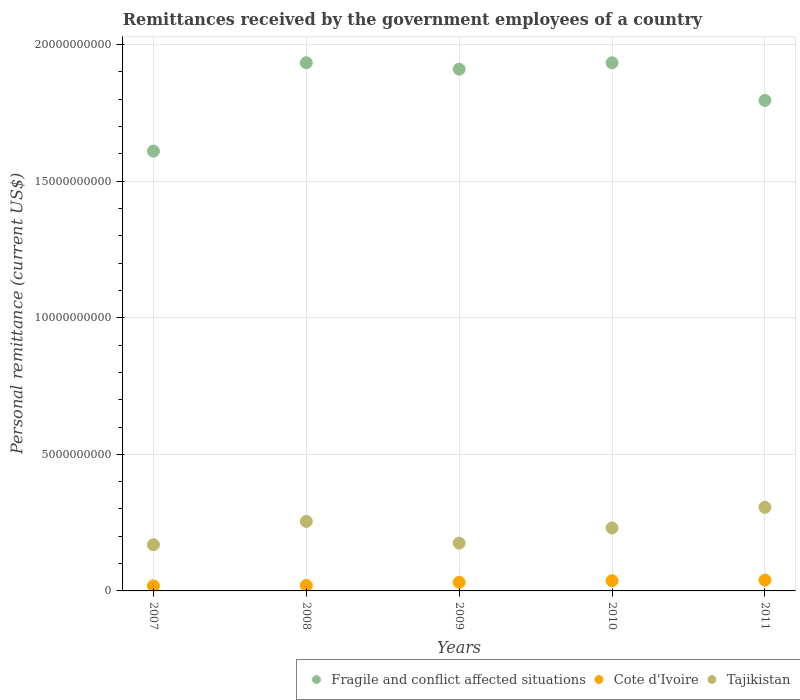What is the remittances received by the government employees in Fragile and conflict affected situations in 2007?
Offer a very short reply. 1.61e+1. Across all years, what is the maximum remittances received by the government employees in Tajikistan?
Your answer should be very brief. 3.06e+09. Across all years, what is the minimum remittances received by the government employees in Fragile and conflict affected situations?
Offer a very short reply. 1.61e+1. In which year was the remittances received by the government employees in Cote d'Ivoire minimum?
Your response must be concise. 2007. What is the total remittances received by the government employees in Fragile and conflict affected situations in the graph?
Provide a short and direct response. 9.18e+1. What is the difference between the remittances received by the government employees in Cote d'Ivoire in 2007 and that in 2011?
Make the answer very short. -2.12e+08. What is the difference between the remittances received by the government employees in Tajikistan in 2007 and the remittances received by the government employees in Cote d'Ivoire in 2009?
Provide a short and direct response. 1.38e+09. What is the average remittances received by the government employees in Tajikistan per year?
Provide a succinct answer. 2.27e+09. In the year 2010, what is the difference between the remittances received by the government employees in Cote d'Ivoire and remittances received by the government employees in Fragile and conflict affected situations?
Offer a very short reply. -1.90e+1. In how many years, is the remittances received by the government employees in Fragile and conflict affected situations greater than 4000000000 US$?
Ensure brevity in your answer.  5. What is the ratio of the remittances received by the government employees in Cote d'Ivoire in 2007 to that in 2010?
Provide a succinct answer. 0.49. Is the difference between the remittances received by the government employees in Cote d'Ivoire in 2010 and 2011 greater than the difference between the remittances received by the government employees in Fragile and conflict affected situations in 2010 and 2011?
Your response must be concise. No. What is the difference between the highest and the second highest remittances received by the government employees in Fragile and conflict affected situations?
Provide a short and direct response. 2.06e+06. What is the difference between the highest and the lowest remittances received by the government employees in Cote d'Ivoire?
Make the answer very short. 2.12e+08. Is the sum of the remittances received by the government employees in Tajikistan in 2008 and 2011 greater than the maximum remittances received by the government employees in Fragile and conflict affected situations across all years?
Your answer should be very brief. No. Is it the case that in every year, the sum of the remittances received by the government employees in Cote d'Ivoire and remittances received by the government employees in Fragile and conflict affected situations  is greater than the remittances received by the government employees in Tajikistan?
Give a very brief answer. Yes. Does the remittances received by the government employees in Tajikistan monotonically increase over the years?
Keep it short and to the point. No. Is the remittances received by the government employees in Tajikistan strictly greater than the remittances received by the government employees in Fragile and conflict affected situations over the years?
Offer a very short reply. No. How many dotlines are there?
Make the answer very short. 3. How many years are there in the graph?
Provide a succinct answer. 5. Are the values on the major ticks of Y-axis written in scientific E-notation?
Your response must be concise. No. Does the graph contain any zero values?
Your response must be concise. No. Does the graph contain grids?
Give a very brief answer. Yes. Where does the legend appear in the graph?
Keep it short and to the point. Bottom right. How many legend labels are there?
Your answer should be compact. 3. How are the legend labels stacked?
Ensure brevity in your answer.  Horizontal. What is the title of the graph?
Ensure brevity in your answer.  Remittances received by the government employees of a country. What is the label or title of the X-axis?
Provide a succinct answer. Years. What is the label or title of the Y-axis?
Make the answer very short. Personal remittance (current US$). What is the Personal remittance (current US$) of Fragile and conflict affected situations in 2007?
Give a very brief answer. 1.61e+1. What is the Personal remittance (current US$) in Cote d'Ivoire in 2007?
Make the answer very short. 1.85e+08. What is the Personal remittance (current US$) of Tajikistan in 2007?
Keep it short and to the point. 1.69e+09. What is the Personal remittance (current US$) of Fragile and conflict affected situations in 2008?
Keep it short and to the point. 1.93e+1. What is the Personal remittance (current US$) of Cote d'Ivoire in 2008?
Offer a terse response. 1.99e+08. What is the Personal remittance (current US$) in Tajikistan in 2008?
Give a very brief answer. 2.54e+09. What is the Personal remittance (current US$) in Fragile and conflict affected situations in 2009?
Ensure brevity in your answer.  1.91e+1. What is the Personal remittance (current US$) in Cote d'Ivoire in 2009?
Provide a short and direct response. 3.15e+08. What is the Personal remittance (current US$) in Tajikistan in 2009?
Give a very brief answer. 1.75e+09. What is the Personal remittance (current US$) of Fragile and conflict affected situations in 2010?
Offer a very short reply. 1.93e+1. What is the Personal remittance (current US$) of Cote d'Ivoire in 2010?
Your response must be concise. 3.73e+08. What is the Personal remittance (current US$) in Tajikistan in 2010?
Provide a short and direct response. 2.31e+09. What is the Personal remittance (current US$) of Fragile and conflict affected situations in 2011?
Ensure brevity in your answer.  1.80e+1. What is the Personal remittance (current US$) of Cote d'Ivoire in 2011?
Offer a terse response. 3.97e+08. What is the Personal remittance (current US$) of Tajikistan in 2011?
Provide a short and direct response. 3.06e+09. Across all years, what is the maximum Personal remittance (current US$) in Fragile and conflict affected situations?
Offer a terse response. 1.93e+1. Across all years, what is the maximum Personal remittance (current US$) of Cote d'Ivoire?
Keep it short and to the point. 3.97e+08. Across all years, what is the maximum Personal remittance (current US$) in Tajikistan?
Keep it short and to the point. 3.06e+09. Across all years, what is the minimum Personal remittance (current US$) of Fragile and conflict affected situations?
Make the answer very short. 1.61e+1. Across all years, what is the minimum Personal remittance (current US$) of Cote d'Ivoire?
Ensure brevity in your answer.  1.85e+08. Across all years, what is the minimum Personal remittance (current US$) in Tajikistan?
Offer a terse response. 1.69e+09. What is the total Personal remittance (current US$) of Fragile and conflict affected situations in the graph?
Provide a short and direct response. 9.18e+1. What is the total Personal remittance (current US$) in Cote d'Ivoire in the graph?
Your answer should be compact. 1.47e+09. What is the total Personal remittance (current US$) of Tajikistan in the graph?
Offer a terse response. 1.13e+1. What is the difference between the Personal remittance (current US$) of Fragile and conflict affected situations in 2007 and that in 2008?
Provide a succinct answer. -3.24e+09. What is the difference between the Personal remittance (current US$) of Cote d'Ivoire in 2007 and that in 2008?
Provide a short and direct response. -1.42e+07. What is the difference between the Personal remittance (current US$) in Tajikistan in 2007 and that in 2008?
Provide a short and direct response. -8.53e+08. What is the difference between the Personal remittance (current US$) in Fragile and conflict affected situations in 2007 and that in 2009?
Provide a succinct answer. -3.00e+09. What is the difference between the Personal remittance (current US$) of Cote d'Ivoire in 2007 and that in 2009?
Ensure brevity in your answer.  -1.30e+08. What is the difference between the Personal remittance (current US$) of Tajikistan in 2007 and that in 2009?
Offer a very short reply. -5.74e+07. What is the difference between the Personal remittance (current US$) in Fragile and conflict affected situations in 2007 and that in 2010?
Your answer should be very brief. -3.23e+09. What is the difference between the Personal remittance (current US$) of Cote d'Ivoire in 2007 and that in 2010?
Provide a succinct answer. -1.89e+08. What is the difference between the Personal remittance (current US$) in Tajikistan in 2007 and that in 2010?
Give a very brief answer. -6.15e+08. What is the difference between the Personal remittance (current US$) in Fragile and conflict affected situations in 2007 and that in 2011?
Provide a short and direct response. -1.86e+09. What is the difference between the Personal remittance (current US$) in Cote d'Ivoire in 2007 and that in 2011?
Offer a very short reply. -2.12e+08. What is the difference between the Personal remittance (current US$) of Tajikistan in 2007 and that in 2011?
Offer a very short reply. -1.37e+09. What is the difference between the Personal remittance (current US$) in Fragile and conflict affected situations in 2008 and that in 2009?
Your response must be concise. 2.36e+08. What is the difference between the Personal remittance (current US$) of Cote d'Ivoire in 2008 and that in 2009?
Give a very brief answer. -1.16e+08. What is the difference between the Personal remittance (current US$) of Tajikistan in 2008 and that in 2009?
Ensure brevity in your answer.  7.96e+08. What is the difference between the Personal remittance (current US$) in Fragile and conflict affected situations in 2008 and that in 2010?
Make the answer very short. 2.06e+06. What is the difference between the Personal remittance (current US$) in Cote d'Ivoire in 2008 and that in 2010?
Provide a succinct answer. -1.75e+08. What is the difference between the Personal remittance (current US$) in Tajikistan in 2008 and that in 2010?
Ensure brevity in your answer.  2.38e+08. What is the difference between the Personal remittance (current US$) of Fragile and conflict affected situations in 2008 and that in 2011?
Keep it short and to the point. 1.38e+09. What is the difference between the Personal remittance (current US$) in Cote d'Ivoire in 2008 and that in 2011?
Ensure brevity in your answer.  -1.98e+08. What is the difference between the Personal remittance (current US$) of Tajikistan in 2008 and that in 2011?
Make the answer very short. -5.16e+08. What is the difference between the Personal remittance (current US$) of Fragile and conflict affected situations in 2009 and that in 2010?
Offer a very short reply. -2.34e+08. What is the difference between the Personal remittance (current US$) in Cote d'Ivoire in 2009 and that in 2010?
Provide a succinct answer. -5.84e+07. What is the difference between the Personal remittance (current US$) of Tajikistan in 2009 and that in 2010?
Provide a succinct answer. -5.58e+08. What is the difference between the Personal remittance (current US$) of Fragile and conflict affected situations in 2009 and that in 2011?
Your answer should be compact. 1.14e+09. What is the difference between the Personal remittance (current US$) of Cote d'Ivoire in 2009 and that in 2011?
Offer a terse response. -8.15e+07. What is the difference between the Personal remittance (current US$) in Tajikistan in 2009 and that in 2011?
Your answer should be very brief. -1.31e+09. What is the difference between the Personal remittance (current US$) in Fragile and conflict affected situations in 2010 and that in 2011?
Ensure brevity in your answer.  1.38e+09. What is the difference between the Personal remittance (current US$) in Cote d'Ivoire in 2010 and that in 2011?
Your answer should be very brief. -2.31e+07. What is the difference between the Personal remittance (current US$) of Tajikistan in 2010 and that in 2011?
Ensure brevity in your answer.  -7.54e+08. What is the difference between the Personal remittance (current US$) of Fragile and conflict affected situations in 2007 and the Personal remittance (current US$) of Cote d'Ivoire in 2008?
Keep it short and to the point. 1.59e+1. What is the difference between the Personal remittance (current US$) in Fragile and conflict affected situations in 2007 and the Personal remittance (current US$) in Tajikistan in 2008?
Provide a short and direct response. 1.36e+1. What is the difference between the Personal remittance (current US$) of Cote d'Ivoire in 2007 and the Personal remittance (current US$) of Tajikistan in 2008?
Your answer should be compact. -2.36e+09. What is the difference between the Personal remittance (current US$) in Fragile and conflict affected situations in 2007 and the Personal remittance (current US$) in Cote d'Ivoire in 2009?
Give a very brief answer. 1.58e+1. What is the difference between the Personal remittance (current US$) in Fragile and conflict affected situations in 2007 and the Personal remittance (current US$) in Tajikistan in 2009?
Make the answer very short. 1.43e+1. What is the difference between the Personal remittance (current US$) in Cote d'Ivoire in 2007 and the Personal remittance (current US$) in Tajikistan in 2009?
Ensure brevity in your answer.  -1.56e+09. What is the difference between the Personal remittance (current US$) in Fragile and conflict affected situations in 2007 and the Personal remittance (current US$) in Cote d'Ivoire in 2010?
Your answer should be very brief. 1.57e+1. What is the difference between the Personal remittance (current US$) of Fragile and conflict affected situations in 2007 and the Personal remittance (current US$) of Tajikistan in 2010?
Offer a very short reply. 1.38e+1. What is the difference between the Personal remittance (current US$) in Cote d'Ivoire in 2007 and the Personal remittance (current US$) in Tajikistan in 2010?
Ensure brevity in your answer.  -2.12e+09. What is the difference between the Personal remittance (current US$) in Fragile and conflict affected situations in 2007 and the Personal remittance (current US$) in Cote d'Ivoire in 2011?
Your answer should be compact. 1.57e+1. What is the difference between the Personal remittance (current US$) of Fragile and conflict affected situations in 2007 and the Personal remittance (current US$) of Tajikistan in 2011?
Make the answer very short. 1.30e+1. What is the difference between the Personal remittance (current US$) in Cote d'Ivoire in 2007 and the Personal remittance (current US$) in Tajikistan in 2011?
Your answer should be compact. -2.88e+09. What is the difference between the Personal remittance (current US$) of Fragile and conflict affected situations in 2008 and the Personal remittance (current US$) of Cote d'Ivoire in 2009?
Your response must be concise. 1.90e+1. What is the difference between the Personal remittance (current US$) in Fragile and conflict affected situations in 2008 and the Personal remittance (current US$) in Tajikistan in 2009?
Give a very brief answer. 1.76e+1. What is the difference between the Personal remittance (current US$) of Cote d'Ivoire in 2008 and the Personal remittance (current US$) of Tajikistan in 2009?
Provide a succinct answer. -1.55e+09. What is the difference between the Personal remittance (current US$) in Fragile and conflict affected situations in 2008 and the Personal remittance (current US$) in Cote d'Ivoire in 2010?
Give a very brief answer. 1.90e+1. What is the difference between the Personal remittance (current US$) in Fragile and conflict affected situations in 2008 and the Personal remittance (current US$) in Tajikistan in 2010?
Your answer should be compact. 1.70e+1. What is the difference between the Personal remittance (current US$) of Cote d'Ivoire in 2008 and the Personal remittance (current US$) of Tajikistan in 2010?
Ensure brevity in your answer.  -2.11e+09. What is the difference between the Personal remittance (current US$) of Fragile and conflict affected situations in 2008 and the Personal remittance (current US$) of Cote d'Ivoire in 2011?
Offer a very short reply. 1.89e+1. What is the difference between the Personal remittance (current US$) in Fragile and conflict affected situations in 2008 and the Personal remittance (current US$) in Tajikistan in 2011?
Make the answer very short. 1.63e+1. What is the difference between the Personal remittance (current US$) in Cote d'Ivoire in 2008 and the Personal remittance (current US$) in Tajikistan in 2011?
Offer a terse response. -2.86e+09. What is the difference between the Personal remittance (current US$) of Fragile and conflict affected situations in 2009 and the Personal remittance (current US$) of Cote d'Ivoire in 2010?
Provide a short and direct response. 1.87e+1. What is the difference between the Personal remittance (current US$) in Fragile and conflict affected situations in 2009 and the Personal remittance (current US$) in Tajikistan in 2010?
Ensure brevity in your answer.  1.68e+1. What is the difference between the Personal remittance (current US$) in Cote d'Ivoire in 2009 and the Personal remittance (current US$) in Tajikistan in 2010?
Make the answer very short. -1.99e+09. What is the difference between the Personal remittance (current US$) in Fragile and conflict affected situations in 2009 and the Personal remittance (current US$) in Cote d'Ivoire in 2011?
Your response must be concise. 1.87e+1. What is the difference between the Personal remittance (current US$) of Fragile and conflict affected situations in 2009 and the Personal remittance (current US$) of Tajikistan in 2011?
Offer a terse response. 1.60e+1. What is the difference between the Personal remittance (current US$) of Cote d'Ivoire in 2009 and the Personal remittance (current US$) of Tajikistan in 2011?
Provide a succinct answer. -2.74e+09. What is the difference between the Personal remittance (current US$) of Fragile and conflict affected situations in 2010 and the Personal remittance (current US$) of Cote d'Ivoire in 2011?
Offer a terse response. 1.89e+1. What is the difference between the Personal remittance (current US$) of Fragile and conflict affected situations in 2010 and the Personal remittance (current US$) of Tajikistan in 2011?
Offer a very short reply. 1.63e+1. What is the difference between the Personal remittance (current US$) in Cote d'Ivoire in 2010 and the Personal remittance (current US$) in Tajikistan in 2011?
Your answer should be very brief. -2.69e+09. What is the average Personal remittance (current US$) in Fragile and conflict affected situations per year?
Provide a succinct answer. 1.84e+1. What is the average Personal remittance (current US$) of Cote d'Ivoire per year?
Your answer should be very brief. 2.94e+08. What is the average Personal remittance (current US$) of Tajikistan per year?
Offer a very short reply. 2.27e+09. In the year 2007, what is the difference between the Personal remittance (current US$) of Fragile and conflict affected situations and Personal remittance (current US$) of Cote d'Ivoire?
Your response must be concise. 1.59e+1. In the year 2007, what is the difference between the Personal remittance (current US$) in Fragile and conflict affected situations and Personal remittance (current US$) in Tajikistan?
Provide a succinct answer. 1.44e+1. In the year 2007, what is the difference between the Personal remittance (current US$) of Cote d'Ivoire and Personal remittance (current US$) of Tajikistan?
Keep it short and to the point. -1.51e+09. In the year 2008, what is the difference between the Personal remittance (current US$) in Fragile and conflict affected situations and Personal remittance (current US$) in Cote d'Ivoire?
Your answer should be very brief. 1.91e+1. In the year 2008, what is the difference between the Personal remittance (current US$) of Fragile and conflict affected situations and Personal remittance (current US$) of Tajikistan?
Ensure brevity in your answer.  1.68e+1. In the year 2008, what is the difference between the Personal remittance (current US$) in Cote d'Ivoire and Personal remittance (current US$) in Tajikistan?
Make the answer very short. -2.35e+09. In the year 2009, what is the difference between the Personal remittance (current US$) in Fragile and conflict affected situations and Personal remittance (current US$) in Cote d'Ivoire?
Your answer should be compact. 1.88e+1. In the year 2009, what is the difference between the Personal remittance (current US$) of Fragile and conflict affected situations and Personal remittance (current US$) of Tajikistan?
Give a very brief answer. 1.73e+1. In the year 2009, what is the difference between the Personal remittance (current US$) in Cote d'Ivoire and Personal remittance (current US$) in Tajikistan?
Give a very brief answer. -1.43e+09. In the year 2010, what is the difference between the Personal remittance (current US$) in Fragile and conflict affected situations and Personal remittance (current US$) in Cote d'Ivoire?
Offer a terse response. 1.90e+1. In the year 2010, what is the difference between the Personal remittance (current US$) in Fragile and conflict affected situations and Personal remittance (current US$) in Tajikistan?
Your answer should be very brief. 1.70e+1. In the year 2010, what is the difference between the Personal remittance (current US$) in Cote d'Ivoire and Personal remittance (current US$) in Tajikistan?
Provide a short and direct response. -1.93e+09. In the year 2011, what is the difference between the Personal remittance (current US$) of Fragile and conflict affected situations and Personal remittance (current US$) of Cote d'Ivoire?
Provide a succinct answer. 1.76e+1. In the year 2011, what is the difference between the Personal remittance (current US$) in Fragile and conflict affected situations and Personal remittance (current US$) in Tajikistan?
Make the answer very short. 1.49e+1. In the year 2011, what is the difference between the Personal remittance (current US$) in Cote d'Ivoire and Personal remittance (current US$) in Tajikistan?
Make the answer very short. -2.66e+09. What is the ratio of the Personal remittance (current US$) in Fragile and conflict affected situations in 2007 to that in 2008?
Provide a succinct answer. 0.83. What is the ratio of the Personal remittance (current US$) of Cote d'Ivoire in 2007 to that in 2008?
Keep it short and to the point. 0.93. What is the ratio of the Personal remittance (current US$) in Tajikistan in 2007 to that in 2008?
Keep it short and to the point. 0.66. What is the ratio of the Personal remittance (current US$) of Fragile and conflict affected situations in 2007 to that in 2009?
Give a very brief answer. 0.84. What is the ratio of the Personal remittance (current US$) of Cote d'Ivoire in 2007 to that in 2009?
Give a very brief answer. 0.59. What is the ratio of the Personal remittance (current US$) of Tajikistan in 2007 to that in 2009?
Provide a short and direct response. 0.97. What is the ratio of the Personal remittance (current US$) in Fragile and conflict affected situations in 2007 to that in 2010?
Give a very brief answer. 0.83. What is the ratio of the Personal remittance (current US$) in Cote d'Ivoire in 2007 to that in 2010?
Provide a short and direct response. 0.49. What is the ratio of the Personal remittance (current US$) of Tajikistan in 2007 to that in 2010?
Provide a succinct answer. 0.73. What is the ratio of the Personal remittance (current US$) of Fragile and conflict affected situations in 2007 to that in 2011?
Keep it short and to the point. 0.9. What is the ratio of the Personal remittance (current US$) in Cote d'Ivoire in 2007 to that in 2011?
Your answer should be very brief. 0.47. What is the ratio of the Personal remittance (current US$) in Tajikistan in 2007 to that in 2011?
Keep it short and to the point. 0.55. What is the ratio of the Personal remittance (current US$) in Fragile and conflict affected situations in 2008 to that in 2009?
Give a very brief answer. 1.01. What is the ratio of the Personal remittance (current US$) in Cote d'Ivoire in 2008 to that in 2009?
Provide a short and direct response. 0.63. What is the ratio of the Personal remittance (current US$) in Tajikistan in 2008 to that in 2009?
Your response must be concise. 1.46. What is the ratio of the Personal remittance (current US$) in Cote d'Ivoire in 2008 to that in 2010?
Provide a short and direct response. 0.53. What is the ratio of the Personal remittance (current US$) in Tajikistan in 2008 to that in 2010?
Ensure brevity in your answer.  1.1. What is the ratio of the Personal remittance (current US$) of Fragile and conflict affected situations in 2008 to that in 2011?
Offer a very short reply. 1.08. What is the ratio of the Personal remittance (current US$) of Cote d'Ivoire in 2008 to that in 2011?
Your answer should be very brief. 0.5. What is the ratio of the Personal remittance (current US$) in Tajikistan in 2008 to that in 2011?
Your answer should be compact. 0.83. What is the ratio of the Personal remittance (current US$) of Fragile and conflict affected situations in 2009 to that in 2010?
Keep it short and to the point. 0.99. What is the ratio of the Personal remittance (current US$) in Cote d'Ivoire in 2009 to that in 2010?
Offer a very short reply. 0.84. What is the ratio of the Personal remittance (current US$) of Tajikistan in 2009 to that in 2010?
Your response must be concise. 0.76. What is the ratio of the Personal remittance (current US$) in Fragile and conflict affected situations in 2009 to that in 2011?
Provide a short and direct response. 1.06. What is the ratio of the Personal remittance (current US$) of Cote d'Ivoire in 2009 to that in 2011?
Make the answer very short. 0.79. What is the ratio of the Personal remittance (current US$) in Tajikistan in 2009 to that in 2011?
Provide a short and direct response. 0.57. What is the ratio of the Personal remittance (current US$) in Fragile and conflict affected situations in 2010 to that in 2011?
Make the answer very short. 1.08. What is the ratio of the Personal remittance (current US$) of Cote d'Ivoire in 2010 to that in 2011?
Make the answer very short. 0.94. What is the ratio of the Personal remittance (current US$) in Tajikistan in 2010 to that in 2011?
Your answer should be compact. 0.75. What is the difference between the highest and the second highest Personal remittance (current US$) of Fragile and conflict affected situations?
Make the answer very short. 2.06e+06. What is the difference between the highest and the second highest Personal remittance (current US$) of Cote d'Ivoire?
Your response must be concise. 2.31e+07. What is the difference between the highest and the second highest Personal remittance (current US$) in Tajikistan?
Offer a terse response. 5.16e+08. What is the difference between the highest and the lowest Personal remittance (current US$) of Fragile and conflict affected situations?
Make the answer very short. 3.24e+09. What is the difference between the highest and the lowest Personal remittance (current US$) of Cote d'Ivoire?
Your answer should be compact. 2.12e+08. What is the difference between the highest and the lowest Personal remittance (current US$) in Tajikistan?
Make the answer very short. 1.37e+09. 